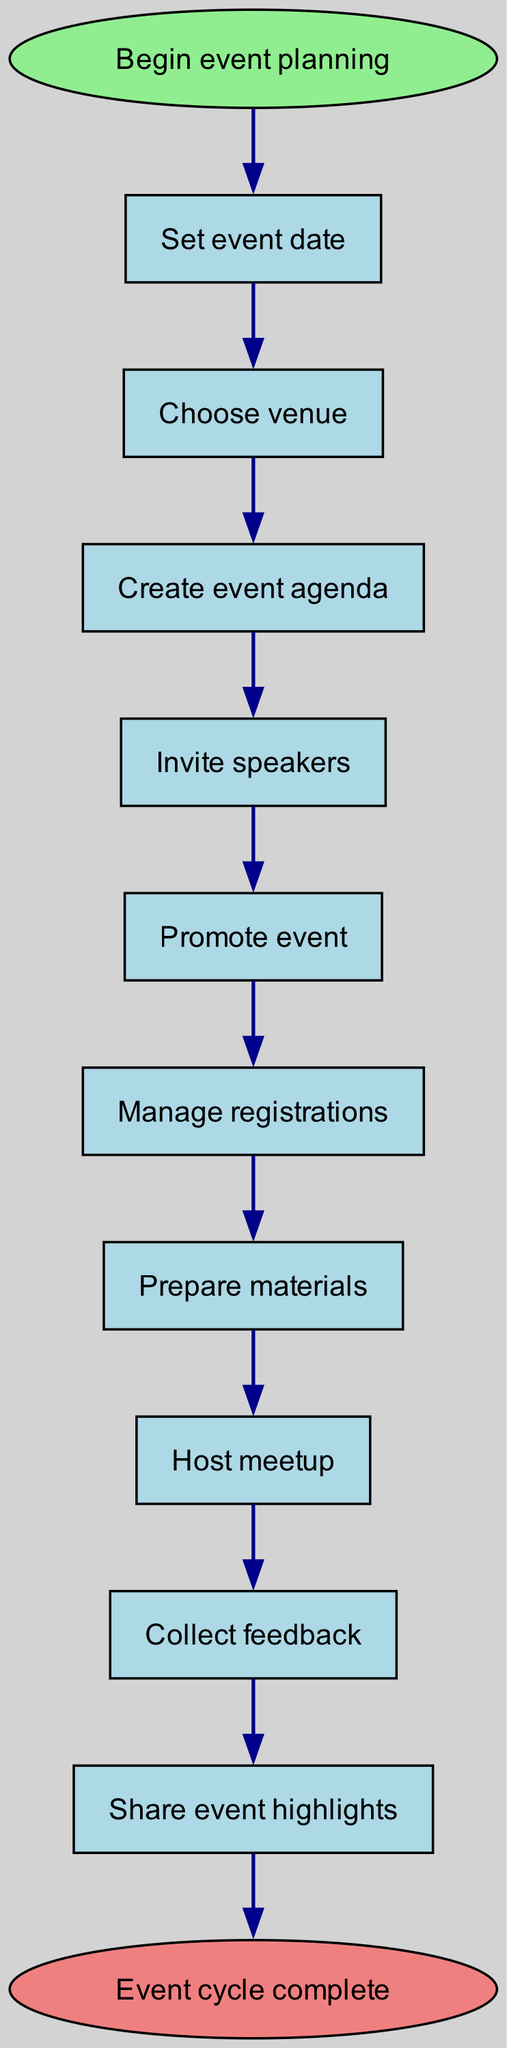What is the first step in the event planning process? The diagram indicates that the first step is labeled "Set event date." This is the initial action taken before any other steps are initiated in the planning process.
Answer: Set event date How many steps are there from start to end? By counting each step in the diagram, there are 10 steps listed between the start and the end node, which represent the entire event planning flow.
Answer: 10 What is the last step before the event cycle is complete? According to the diagram, the last step before the event cycle completes is "Share event highlights." This indicates the final action taken before concluding the planning cycle.
Answer: Share event highlights Which step follows "Manage registrations"? The diagram clearly shows that the step that follows "Manage registrations" is "Prepare materials." This is a direct transition in the flow of tasks.
Answer: Prepare materials What is the relationship between "Invite speakers" and "Promote event"? The diagram displays a direct flow from "Invite speakers" to "Promote event," indicating that after speakers are invited, the next task is to promote the event.
Answer: Direct flow How does "Collect feedback" fit into the overall event planning process? "Collect feedback" is positioned after hosting the meetup, highlighting its role in gathering participant responses to improve future events. It serves as an evaluative step in the overall process.
Answer: Evaluative step Which step has no preceding steps? The first step listed in the diagram is "Set event date," and it does not have any preceding steps as it's the initial action in the planning process.
Answer: Set event date If the "Host meetup" step fails, which step is impacted next? If "Host meetup" is unsuccessful, the next step "Collect feedback" would be impacted, as feedback can only be collected after the event has been hosted.
Answer: Collect feedback What color denotes the end of the event planning cycle in the diagram? The end of the event planning cycle is represented by the node "Event cycle complete," which is colored light coral in the diagram, indicating completion.
Answer: Light coral 